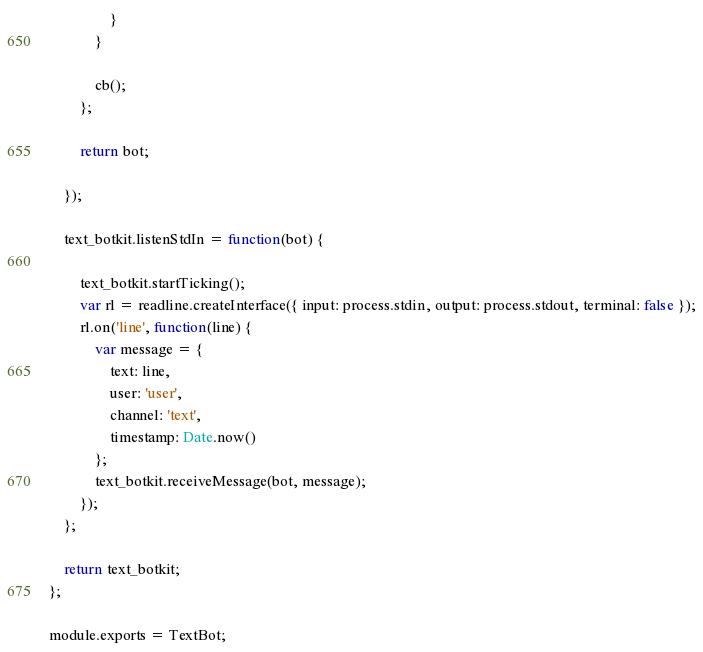Convert code to text. <code><loc_0><loc_0><loc_500><loc_500><_JavaScript_>                }
            }

            cb();
        };

        return bot;

    });

    text_botkit.listenStdIn = function(bot) {

        text_botkit.startTicking();
        var rl = readline.createInterface({ input: process.stdin, output: process.stdout, terminal: false });
        rl.on('line', function(line) {
            var message = {
                text: line,
                user: 'user',
                channel: 'text',
                timestamp: Date.now()
            };
            text_botkit.receiveMessage(bot, message);
        });
    };

    return text_botkit;
};

module.exports = TextBot;
</code> 